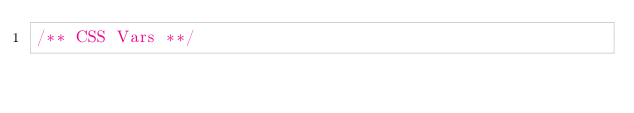<code> <loc_0><loc_0><loc_500><loc_500><_CSS_>/** CSS Vars **/</code> 